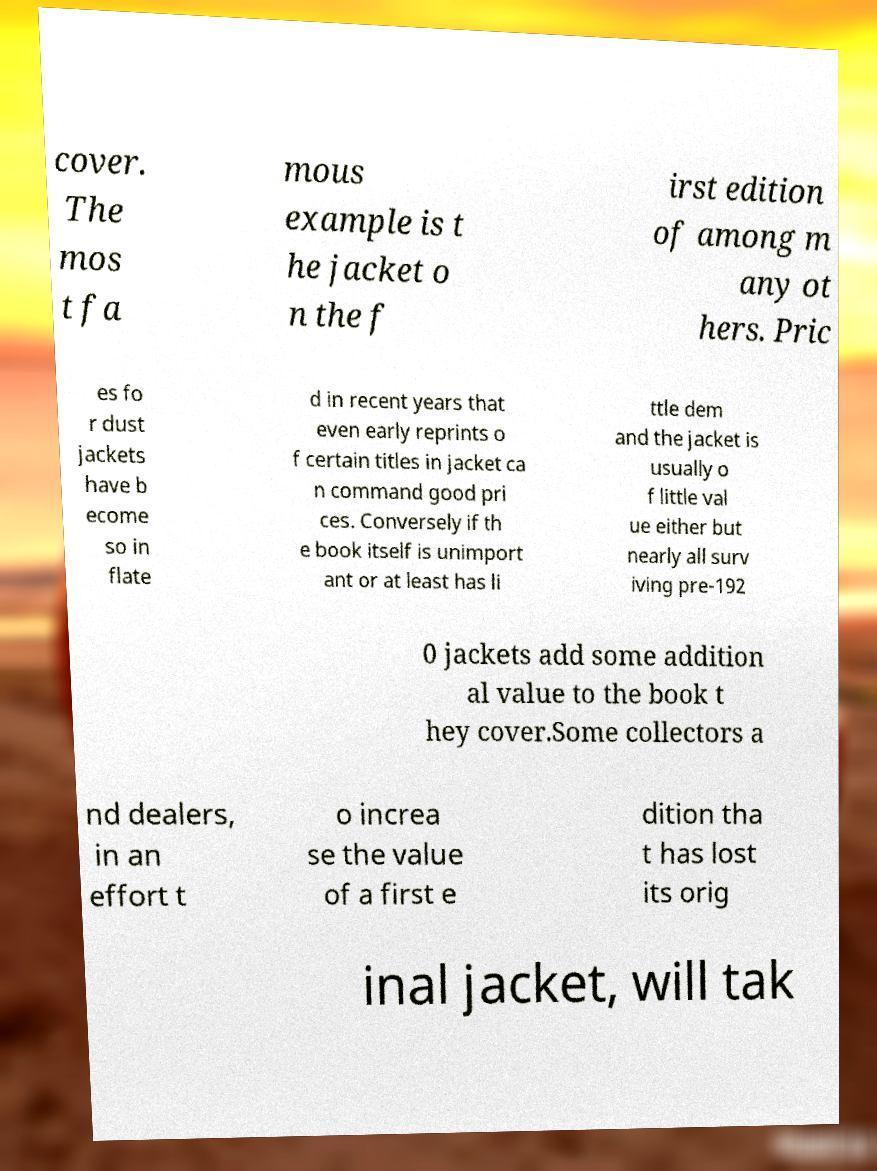Could you extract and type out the text from this image? cover. The mos t fa mous example is t he jacket o n the f irst edition of among m any ot hers. Pric es fo r dust jackets have b ecome so in flate d in recent years that even early reprints o f certain titles in jacket ca n command good pri ces. Conversely if th e book itself is unimport ant or at least has li ttle dem and the jacket is usually o f little val ue either but nearly all surv iving pre-192 0 jackets add some addition al value to the book t hey cover.Some collectors a nd dealers, in an effort t o increa se the value of a first e dition tha t has lost its orig inal jacket, will tak 